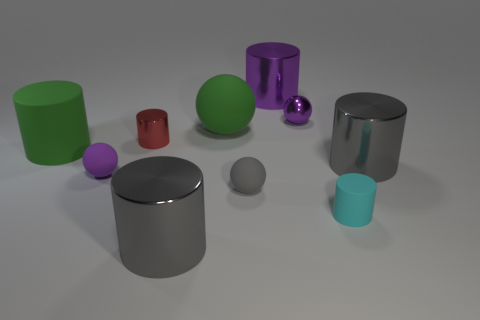Subtract all large rubber balls. How many balls are left? 3 Subtract all balls. How many objects are left? 6 Subtract all gray cylinders. How many gray balls are left? 1 Subtract all large yellow metallic cylinders. Subtract all purple rubber balls. How many objects are left? 9 Add 3 tiny metallic balls. How many tiny metallic balls are left? 4 Add 3 big cyan metallic spheres. How many big cyan metallic spheres exist? 3 Subtract all purple cylinders. How many cylinders are left? 5 Subtract 0 cyan spheres. How many objects are left? 10 Subtract 2 spheres. How many spheres are left? 2 Subtract all red spheres. Subtract all red cylinders. How many spheres are left? 4 